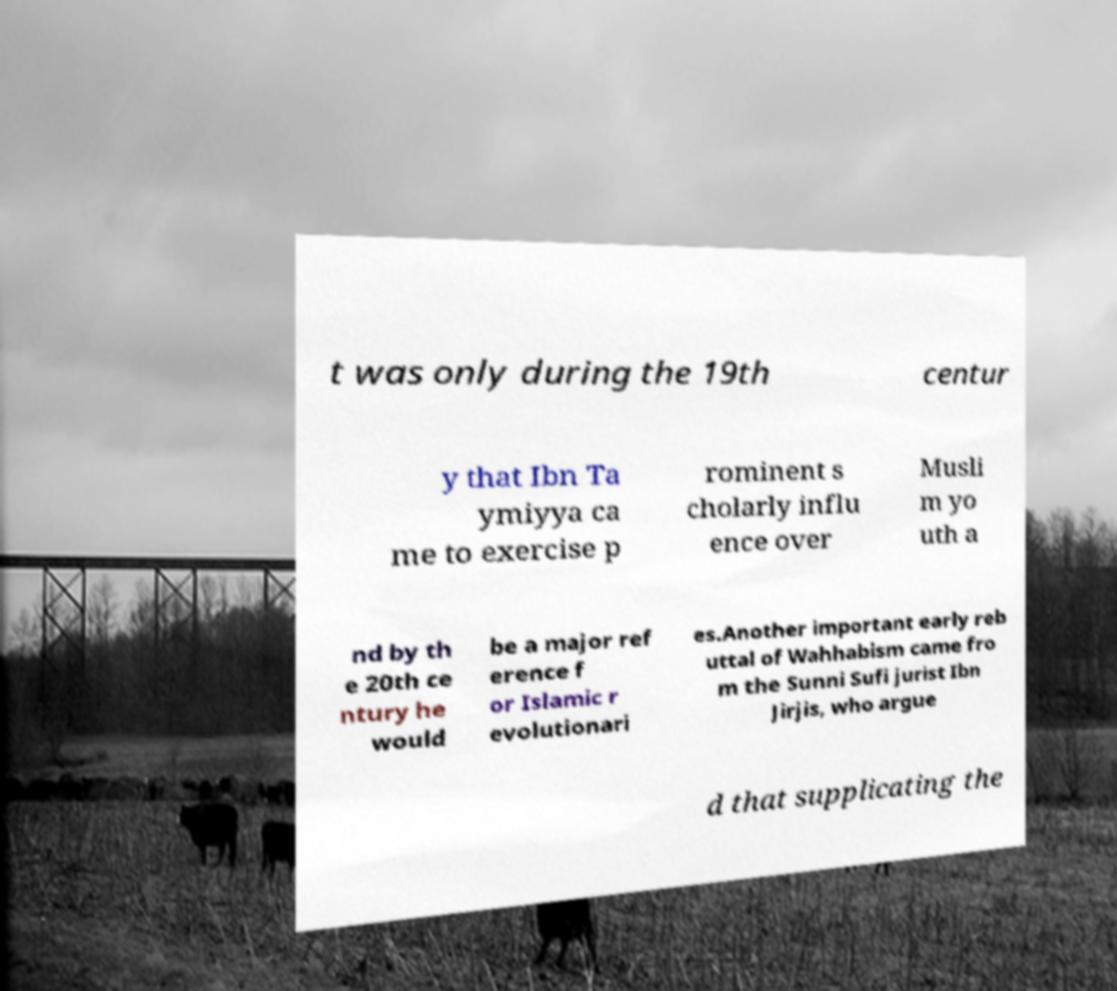Please identify and transcribe the text found in this image. t was only during the 19th centur y that Ibn Ta ymiyya ca me to exercise p rominent s cholarly influ ence over Musli m yo uth a nd by th e 20th ce ntury he would be a major ref erence f or Islamic r evolutionari es.Another important early reb uttal of Wahhabism came fro m the Sunni Sufi jurist Ibn Jirjis, who argue d that supplicating the 